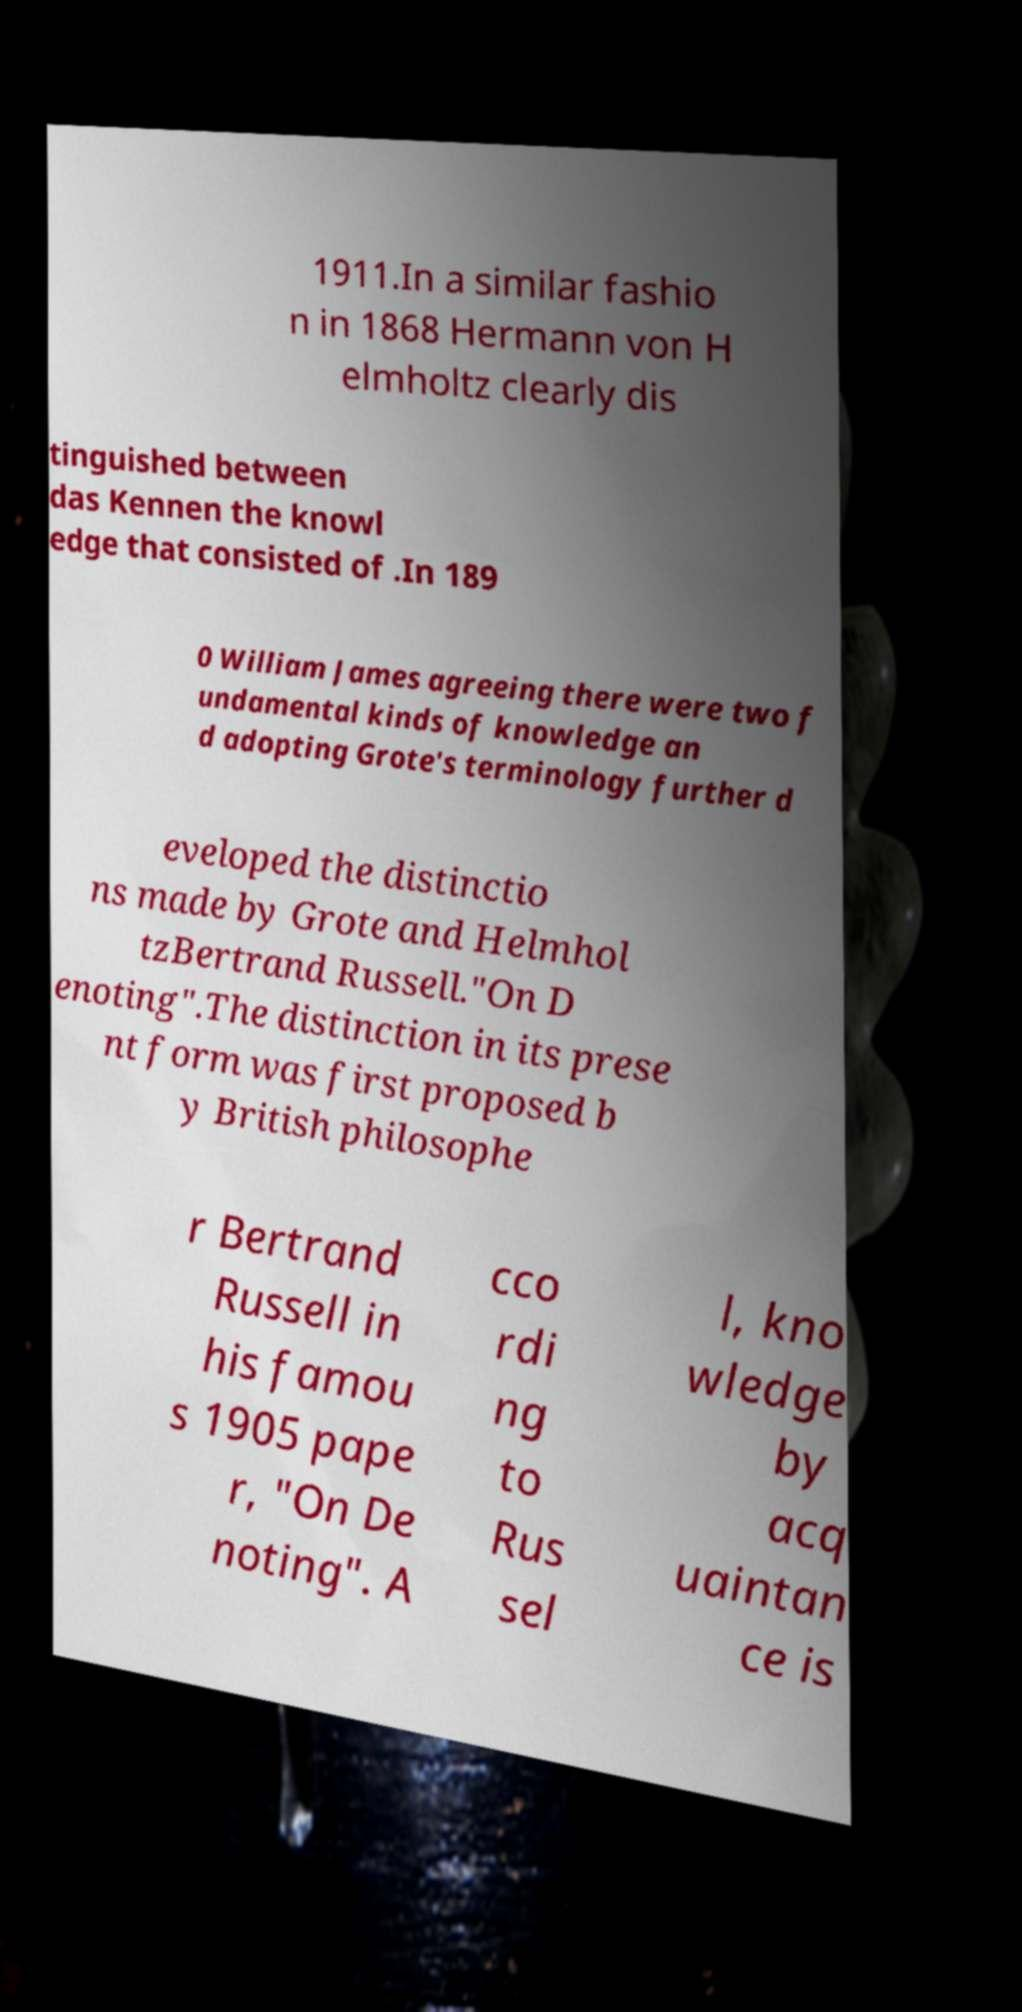Can you read and provide the text displayed in the image?This photo seems to have some interesting text. Can you extract and type it out for me? 1911.In a similar fashio n in 1868 Hermann von H elmholtz clearly dis tinguished between das Kennen the knowl edge that consisted of .In 189 0 William James agreeing there were two f undamental kinds of knowledge an d adopting Grote's terminology further d eveloped the distinctio ns made by Grote and Helmhol tzBertrand Russell."On D enoting".The distinction in its prese nt form was first proposed b y British philosophe r Bertrand Russell in his famou s 1905 pape r, "On De noting". A cco rdi ng to Rus sel l, kno wledge by acq uaintan ce is 